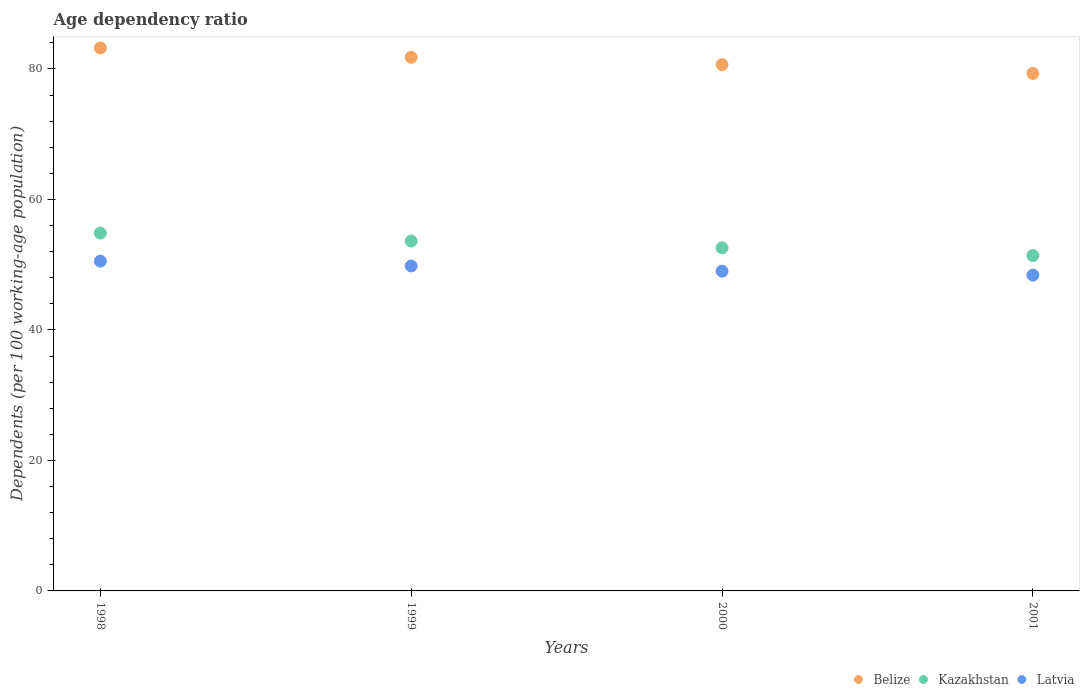How many different coloured dotlines are there?
Ensure brevity in your answer.  3. What is the age dependency ratio in in Kazakhstan in 1998?
Your answer should be compact. 54.85. Across all years, what is the maximum age dependency ratio in in Belize?
Keep it short and to the point. 83.23. Across all years, what is the minimum age dependency ratio in in Kazakhstan?
Provide a short and direct response. 51.4. In which year was the age dependency ratio in in Belize maximum?
Make the answer very short. 1998. What is the total age dependency ratio in in Kazakhstan in the graph?
Make the answer very short. 212.47. What is the difference between the age dependency ratio in in Latvia in 1999 and that in 2001?
Your answer should be very brief. 1.41. What is the difference between the age dependency ratio in in Kazakhstan in 1999 and the age dependency ratio in in Belize in 2001?
Make the answer very short. -25.69. What is the average age dependency ratio in in Latvia per year?
Offer a very short reply. 49.44. In the year 2000, what is the difference between the age dependency ratio in in Kazakhstan and age dependency ratio in in Belize?
Ensure brevity in your answer.  -28.08. What is the ratio of the age dependency ratio in in Kazakhstan in 1998 to that in 1999?
Your response must be concise. 1.02. What is the difference between the highest and the second highest age dependency ratio in in Latvia?
Your answer should be very brief. 0.74. What is the difference between the highest and the lowest age dependency ratio in in Latvia?
Ensure brevity in your answer.  2.15. Is the sum of the age dependency ratio in in Kazakhstan in 1998 and 1999 greater than the maximum age dependency ratio in in Latvia across all years?
Keep it short and to the point. Yes. Is the age dependency ratio in in Belize strictly greater than the age dependency ratio in in Kazakhstan over the years?
Make the answer very short. Yes. Is the age dependency ratio in in Belize strictly less than the age dependency ratio in in Kazakhstan over the years?
Provide a short and direct response. No. What is the difference between two consecutive major ticks on the Y-axis?
Make the answer very short. 20. Are the values on the major ticks of Y-axis written in scientific E-notation?
Give a very brief answer. No. Does the graph contain grids?
Your answer should be very brief. No. How many legend labels are there?
Keep it short and to the point. 3. What is the title of the graph?
Offer a terse response. Age dependency ratio. Does "Suriname" appear as one of the legend labels in the graph?
Ensure brevity in your answer.  No. What is the label or title of the X-axis?
Provide a short and direct response. Years. What is the label or title of the Y-axis?
Your answer should be very brief. Dependents (per 100 working-age population). What is the Dependents (per 100 working-age population) of Belize in 1998?
Provide a succinct answer. 83.23. What is the Dependents (per 100 working-age population) of Kazakhstan in 1998?
Your answer should be very brief. 54.85. What is the Dependents (per 100 working-age population) in Latvia in 1998?
Offer a terse response. 50.55. What is the Dependents (per 100 working-age population) of Belize in 1999?
Offer a very short reply. 81.79. What is the Dependents (per 100 working-age population) in Kazakhstan in 1999?
Provide a short and direct response. 53.63. What is the Dependents (per 100 working-age population) in Latvia in 1999?
Ensure brevity in your answer.  49.81. What is the Dependents (per 100 working-age population) of Belize in 2000?
Ensure brevity in your answer.  80.66. What is the Dependents (per 100 working-age population) of Kazakhstan in 2000?
Your answer should be compact. 52.59. What is the Dependents (per 100 working-age population) of Latvia in 2000?
Offer a very short reply. 49.01. What is the Dependents (per 100 working-age population) of Belize in 2001?
Make the answer very short. 79.32. What is the Dependents (per 100 working-age population) of Kazakhstan in 2001?
Your answer should be compact. 51.4. What is the Dependents (per 100 working-age population) of Latvia in 2001?
Your response must be concise. 48.4. Across all years, what is the maximum Dependents (per 100 working-age population) of Belize?
Your response must be concise. 83.23. Across all years, what is the maximum Dependents (per 100 working-age population) in Kazakhstan?
Your answer should be compact. 54.85. Across all years, what is the maximum Dependents (per 100 working-age population) in Latvia?
Your answer should be compact. 50.55. Across all years, what is the minimum Dependents (per 100 working-age population) of Belize?
Your answer should be compact. 79.32. Across all years, what is the minimum Dependents (per 100 working-age population) in Kazakhstan?
Provide a succinct answer. 51.4. Across all years, what is the minimum Dependents (per 100 working-age population) of Latvia?
Offer a terse response. 48.4. What is the total Dependents (per 100 working-age population) in Belize in the graph?
Your answer should be compact. 325. What is the total Dependents (per 100 working-age population) in Kazakhstan in the graph?
Keep it short and to the point. 212.47. What is the total Dependents (per 100 working-age population) in Latvia in the graph?
Provide a short and direct response. 197.77. What is the difference between the Dependents (per 100 working-age population) of Belize in 1998 and that in 1999?
Provide a succinct answer. 1.44. What is the difference between the Dependents (per 100 working-age population) in Kazakhstan in 1998 and that in 1999?
Ensure brevity in your answer.  1.22. What is the difference between the Dependents (per 100 working-age population) of Latvia in 1998 and that in 1999?
Ensure brevity in your answer.  0.74. What is the difference between the Dependents (per 100 working-age population) in Belize in 1998 and that in 2000?
Offer a very short reply. 2.56. What is the difference between the Dependents (per 100 working-age population) in Kazakhstan in 1998 and that in 2000?
Give a very brief answer. 2.26. What is the difference between the Dependents (per 100 working-age population) of Latvia in 1998 and that in 2000?
Keep it short and to the point. 1.54. What is the difference between the Dependents (per 100 working-age population) in Belize in 1998 and that in 2001?
Your answer should be compact. 3.91. What is the difference between the Dependents (per 100 working-age population) of Kazakhstan in 1998 and that in 2001?
Your answer should be compact. 3.45. What is the difference between the Dependents (per 100 working-age population) in Latvia in 1998 and that in 2001?
Your answer should be compact. 2.15. What is the difference between the Dependents (per 100 working-age population) in Belize in 1999 and that in 2000?
Your response must be concise. 1.12. What is the difference between the Dependents (per 100 working-age population) of Kazakhstan in 1999 and that in 2000?
Your response must be concise. 1.04. What is the difference between the Dependents (per 100 working-age population) of Latvia in 1999 and that in 2000?
Keep it short and to the point. 0.8. What is the difference between the Dependents (per 100 working-age population) of Belize in 1999 and that in 2001?
Provide a succinct answer. 2.47. What is the difference between the Dependents (per 100 working-age population) in Kazakhstan in 1999 and that in 2001?
Offer a very short reply. 2.22. What is the difference between the Dependents (per 100 working-age population) of Latvia in 1999 and that in 2001?
Keep it short and to the point. 1.41. What is the difference between the Dependents (per 100 working-age population) of Belize in 2000 and that in 2001?
Ensure brevity in your answer.  1.34. What is the difference between the Dependents (per 100 working-age population) of Kazakhstan in 2000 and that in 2001?
Your response must be concise. 1.18. What is the difference between the Dependents (per 100 working-age population) of Latvia in 2000 and that in 2001?
Provide a short and direct response. 0.61. What is the difference between the Dependents (per 100 working-age population) of Belize in 1998 and the Dependents (per 100 working-age population) of Kazakhstan in 1999?
Offer a very short reply. 29.6. What is the difference between the Dependents (per 100 working-age population) of Belize in 1998 and the Dependents (per 100 working-age population) of Latvia in 1999?
Your answer should be compact. 33.42. What is the difference between the Dependents (per 100 working-age population) of Kazakhstan in 1998 and the Dependents (per 100 working-age population) of Latvia in 1999?
Make the answer very short. 5.04. What is the difference between the Dependents (per 100 working-age population) of Belize in 1998 and the Dependents (per 100 working-age population) of Kazakhstan in 2000?
Offer a terse response. 30.64. What is the difference between the Dependents (per 100 working-age population) of Belize in 1998 and the Dependents (per 100 working-age population) of Latvia in 2000?
Provide a short and direct response. 34.22. What is the difference between the Dependents (per 100 working-age population) of Kazakhstan in 1998 and the Dependents (per 100 working-age population) of Latvia in 2000?
Make the answer very short. 5.84. What is the difference between the Dependents (per 100 working-age population) of Belize in 1998 and the Dependents (per 100 working-age population) of Kazakhstan in 2001?
Provide a short and direct response. 31.83. What is the difference between the Dependents (per 100 working-age population) of Belize in 1998 and the Dependents (per 100 working-age population) of Latvia in 2001?
Your answer should be very brief. 34.83. What is the difference between the Dependents (per 100 working-age population) in Kazakhstan in 1998 and the Dependents (per 100 working-age population) in Latvia in 2001?
Make the answer very short. 6.45. What is the difference between the Dependents (per 100 working-age population) in Belize in 1999 and the Dependents (per 100 working-age population) in Kazakhstan in 2000?
Your response must be concise. 29.2. What is the difference between the Dependents (per 100 working-age population) in Belize in 1999 and the Dependents (per 100 working-age population) in Latvia in 2000?
Offer a terse response. 32.78. What is the difference between the Dependents (per 100 working-age population) in Kazakhstan in 1999 and the Dependents (per 100 working-age population) in Latvia in 2000?
Provide a succinct answer. 4.62. What is the difference between the Dependents (per 100 working-age population) in Belize in 1999 and the Dependents (per 100 working-age population) in Kazakhstan in 2001?
Offer a terse response. 30.39. What is the difference between the Dependents (per 100 working-age population) in Belize in 1999 and the Dependents (per 100 working-age population) in Latvia in 2001?
Provide a succinct answer. 33.39. What is the difference between the Dependents (per 100 working-age population) in Kazakhstan in 1999 and the Dependents (per 100 working-age population) in Latvia in 2001?
Provide a short and direct response. 5.23. What is the difference between the Dependents (per 100 working-age population) of Belize in 2000 and the Dependents (per 100 working-age population) of Kazakhstan in 2001?
Offer a very short reply. 29.26. What is the difference between the Dependents (per 100 working-age population) of Belize in 2000 and the Dependents (per 100 working-age population) of Latvia in 2001?
Offer a very short reply. 32.27. What is the difference between the Dependents (per 100 working-age population) in Kazakhstan in 2000 and the Dependents (per 100 working-age population) in Latvia in 2001?
Give a very brief answer. 4.19. What is the average Dependents (per 100 working-age population) of Belize per year?
Provide a short and direct response. 81.25. What is the average Dependents (per 100 working-age population) in Kazakhstan per year?
Ensure brevity in your answer.  53.12. What is the average Dependents (per 100 working-age population) of Latvia per year?
Keep it short and to the point. 49.44. In the year 1998, what is the difference between the Dependents (per 100 working-age population) of Belize and Dependents (per 100 working-age population) of Kazakhstan?
Offer a very short reply. 28.38. In the year 1998, what is the difference between the Dependents (per 100 working-age population) of Belize and Dependents (per 100 working-age population) of Latvia?
Give a very brief answer. 32.68. In the year 1998, what is the difference between the Dependents (per 100 working-age population) of Kazakhstan and Dependents (per 100 working-age population) of Latvia?
Your response must be concise. 4.3. In the year 1999, what is the difference between the Dependents (per 100 working-age population) of Belize and Dependents (per 100 working-age population) of Kazakhstan?
Ensure brevity in your answer.  28.16. In the year 1999, what is the difference between the Dependents (per 100 working-age population) in Belize and Dependents (per 100 working-age population) in Latvia?
Make the answer very short. 31.98. In the year 1999, what is the difference between the Dependents (per 100 working-age population) in Kazakhstan and Dependents (per 100 working-age population) in Latvia?
Keep it short and to the point. 3.82. In the year 2000, what is the difference between the Dependents (per 100 working-age population) in Belize and Dependents (per 100 working-age population) in Kazakhstan?
Your answer should be compact. 28.08. In the year 2000, what is the difference between the Dependents (per 100 working-age population) in Belize and Dependents (per 100 working-age population) in Latvia?
Offer a very short reply. 31.65. In the year 2000, what is the difference between the Dependents (per 100 working-age population) of Kazakhstan and Dependents (per 100 working-age population) of Latvia?
Your answer should be very brief. 3.58. In the year 2001, what is the difference between the Dependents (per 100 working-age population) in Belize and Dependents (per 100 working-age population) in Kazakhstan?
Provide a short and direct response. 27.92. In the year 2001, what is the difference between the Dependents (per 100 working-age population) of Belize and Dependents (per 100 working-age population) of Latvia?
Ensure brevity in your answer.  30.92. In the year 2001, what is the difference between the Dependents (per 100 working-age population) of Kazakhstan and Dependents (per 100 working-age population) of Latvia?
Provide a short and direct response. 3. What is the ratio of the Dependents (per 100 working-age population) of Belize in 1998 to that in 1999?
Offer a terse response. 1.02. What is the ratio of the Dependents (per 100 working-age population) of Kazakhstan in 1998 to that in 1999?
Your response must be concise. 1.02. What is the ratio of the Dependents (per 100 working-age population) of Latvia in 1998 to that in 1999?
Your answer should be compact. 1.01. What is the ratio of the Dependents (per 100 working-age population) in Belize in 1998 to that in 2000?
Provide a short and direct response. 1.03. What is the ratio of the Dependents (per 100 working-age population) of Kazakhstan in 1998 to that in 2000?
Your answer should be very brief. 1.04. What is the ratio of the Dependents (per 100 working-age population) in Latvia in 1998 to that in 2000?
Ensure brevity in your answer.  1.03. What is the ratio of the Dependents (per 100 working-age population) in Belize in 1998 to that in 2001?
Make the answer very short. 1.05. What is the ratio of the Dependents (per 100 working-age population) in Kazakhstan in 1998 to that in 2001?
Offer a terse response. 1.07. What is the ratio of the Dependents (per 100 working-age population) in Latvia in 1998 to that in 2001?
Provide a short and direct response. 1.04. What is the ratio of the Dependents (per 100 working-age population) in Belize in 1999 to that in 2000?
Offer a very short reply. 1.01. What is the ratio of the Dependents (per 100 working-age population) of Kazakhstan in 1999 to that in 2000?
Offer a very short reply. 1.02. What is the ratio of the Dependents (per 100 working-age population) of Latvia in 1999 to that in 2000?
Provide a succinct answer. 1.02. What is the ratio of the Dependents (per 100 working-age population) in Belize in 1999 to that in 2001?
Ensure brevity in your answer.  1.03. What is the ratio of the Dependents (per 100 working-age population) of Kazakhstan in 1999 to that in 2001?
Keep it short and to the point. 1.04. What is the ratio of the Dependents (per 100 working-age population) of Latvia in 1999 to that in 2001?
Your response must be concise. 1.03. What is the ratio of the Dependents (per 100 working-age population) in Belize in 2000 to that in 2001?
Keep it short and to the point. 1.02. What is the ratio of the Dependents (per 100 working-age population) of Kazakhstan in 2000 to that in 2001?
Offer a very short reply. 1.02. What is the ratio of the Dependents (per 100 working-age population) of Latvia in 2000 to that in 2001?
Make the answer very short. 1.01. What is the difference between the highest and the second highest Dependents (per 100 working-age population) of Belize?
Your answer should be compact. 1.44. What is the difference between the highest and the second highest Dependents (per 100 working-age population) in Kazakhstan?
Give a very brief answer. 1.22. What is the difference between the highest and the second highest Dependents (per 100 working-age population) in Latvia?
Ensure brevity in your answer.  0.74. What is the difference between the highest and the lowest Dependents (per 100 working-age population) of Belize?
Offer a terse response. 3.91. What is the difference between the highest and the lowest Dependents (per 100 working-age population) of Kazakhstan?
Provide a succinct answer. 3.45. What is the difference between the highest and the lowest Dependents (per 100 working-age population) of Latvia?
Offer a very short reply. 2.15. 